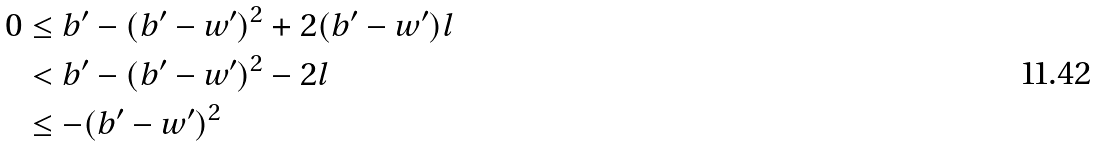Convert formula to latex. <formula><loc_0><loc_0><loc_500><loc_500>0 & \leq b ^ { \prime } - ( b ^ { \prime } - w ^ { \prime } ) ^ { 2 } + 2 ( b ^ { \prime } - w ^ { \prime } ) l \\ & < b ^ { \prime } - ( b ^ { \prime } - w ^ { \prime } ) ^ { 2 } - 2 l \\ & \leq - ( b ^ { \prime } - w ^ { \prime } ) ^ { 2 }</formula> 